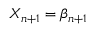<formula> <loc_0><loc_0><loc_500><loc_500>X _ { n + 1 } = \beta _ { n + 1 }</formula> 